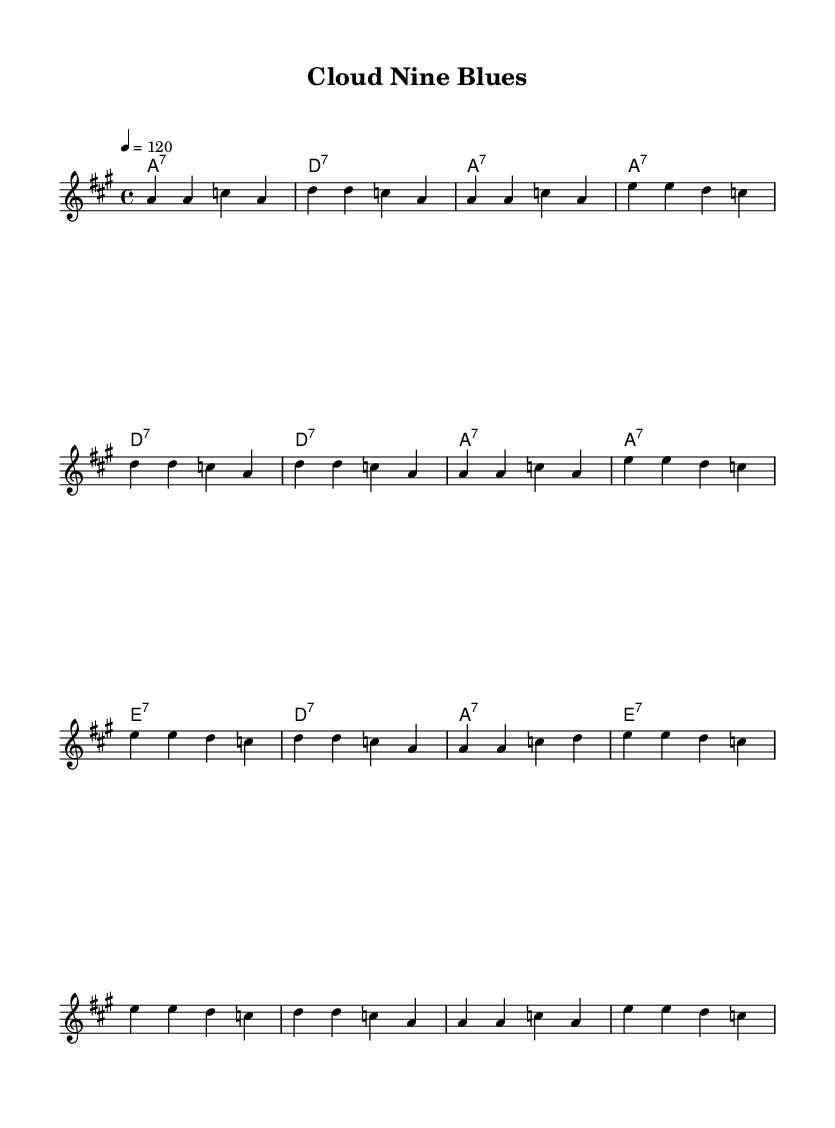What is the key signature of this music? The key signature is A major, indicated by three sharps.
Answer: A major What is the time signature of this piece? The time signature is 4/4, which is shown at the beginning of the score.
Answer: 4/4 What is the tempo marking? The tempo marking is quarter note equals 120, which defines the speed of the piece.
Answer: 120 How many measures are there in the verse? The verse contains eight measures, as seen from the structure of the written music.
Answer: Eight What type of chord primarily accompanies the verse? The verse is primarily accompanied by seventh chords, as indicated in the harmonies section.
Answer: Seventh chords How many lines of lyrics are there in the chorus? There are four lines of lyrics in the chorus, as seen in the lyrics section.
Answer: Four Which element represents the feeling of technological progress in the lyrics? The lyrics reference terms like "digital world" and "cloud computing," symbolizing technological advancement.
Answer: Digital world 